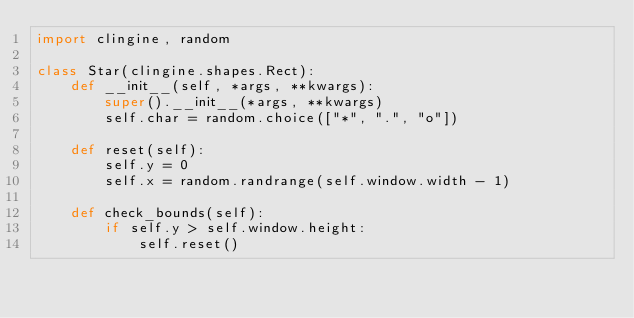<code> <loc_0><loc_0><loc_500><loc_500><_Python_>import clingine, random

class Star(clingine.shapes.Rect):
	def __init__(self, *args, **kwargs):
		super().__init__(*args, **kwargs)
		self.char = random.choice(["*", ".", "o"])

	def reset(self):
		self.y = 0
		self.x = random.randrange(self.window.width - 1)

	def check_bounds(self):
		if self.y > self.window.height:
			self.reset()</code> 